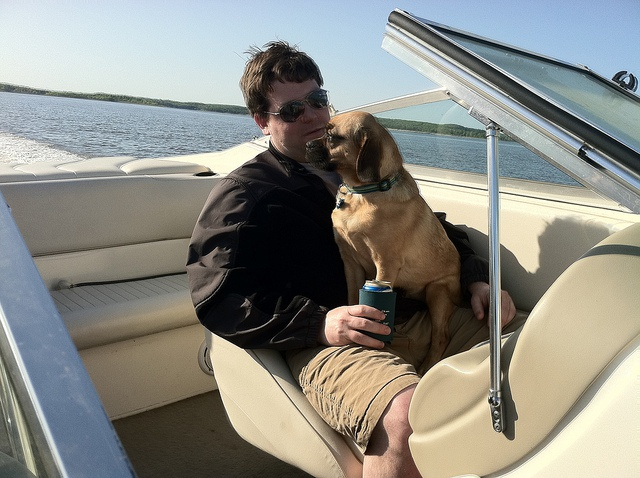Describe the objects in this image and their specific colors. I can see boat in lightgray, gray, beige, tan, and darkgray tones, people in lightgray, black, gray, tan, and maroon tones, dog in lightgray, black, maroon, and gray tones, chair in lightgray, tan, gray, and beige tones, and cup in lightgray, black, gray, and purple tones in this image. 